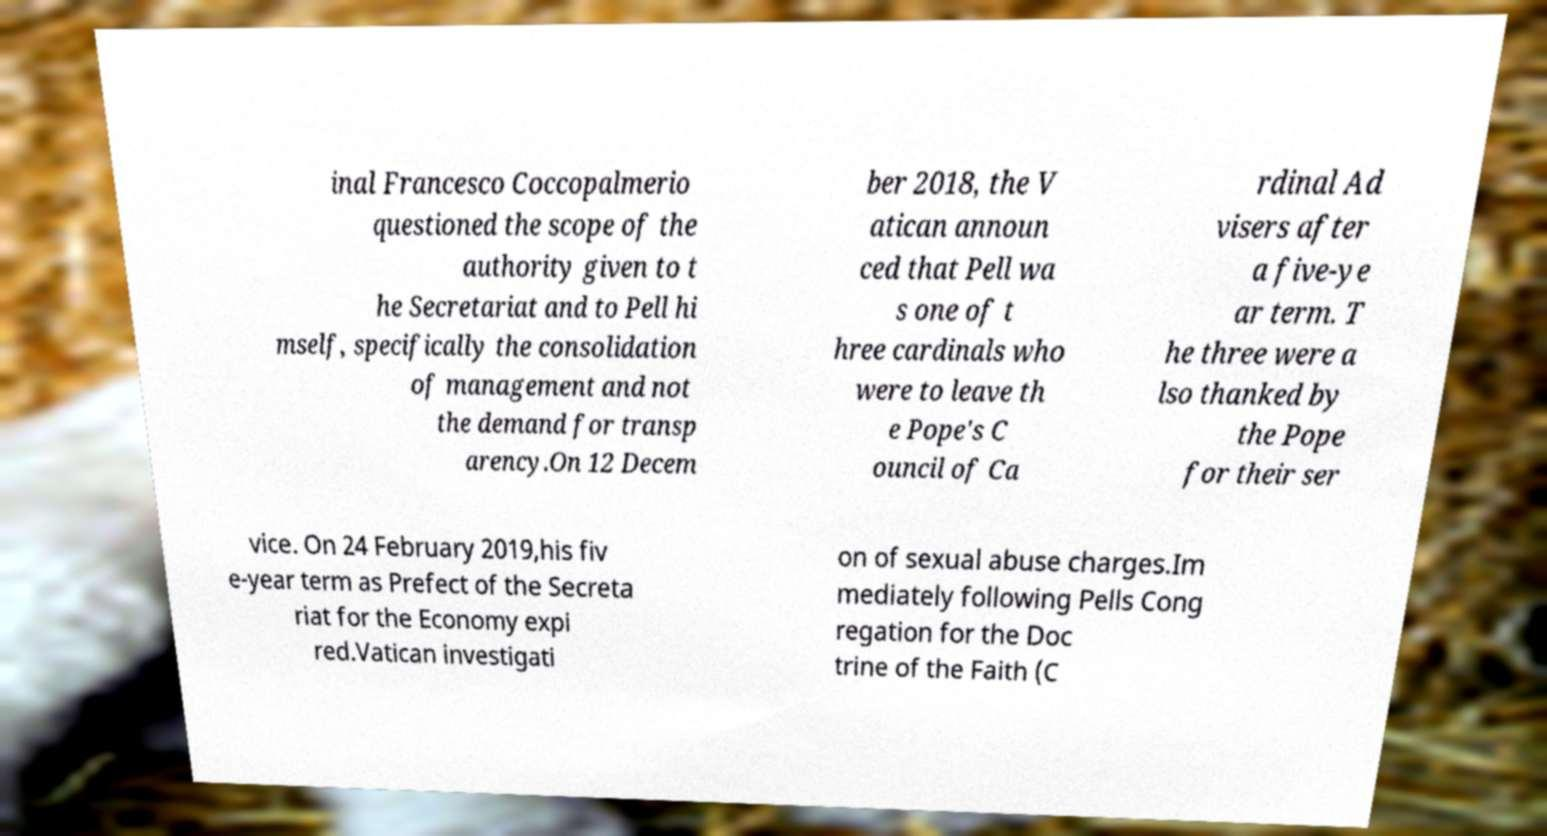Can you read and provide the text displayed in the image?This photo seems to have some interesting text. Can you extract and type it out for me? inal Francesco Coccopalmerio questioned the scope of the authority given to t he Secretariat and to Pell hi mself, specifically the consolidation of management and not the demand for transp arency.On 12 Decem ber 2018, the V atican announ ced that Pell wa s one of t hree cardinals who were to leave th e Pope's C ouncil of Ca rdinal Ad visers after a five-ye ar term. T he three were a lso thanked by the Pope for their ser vice. On 24 February 2019,his fiv e-year term as Prefect of the Secreta riat for the Economy expi red.Vatican investigati on of sexual abuse charges.Im mediately following Pells Cong regation for the Doc trine of the Faith (C 